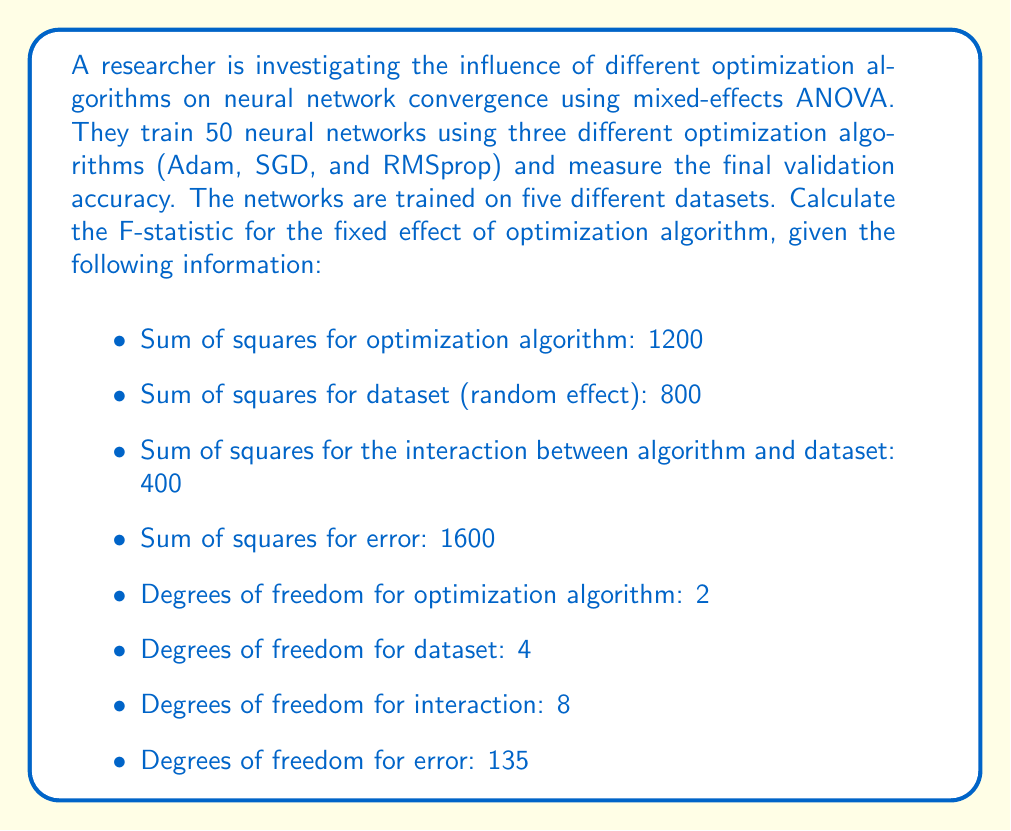Give your solution to this math problem. To calculate the F-statistic for the fixed effect of optimization algorithm in a mixed-effects ANOVA, we need to follow these steps:

1. Calculate the mean square for the optimization algorithm:
   $$MS_{algorithm} = \frac{SS_{algorithm}}{df_{algorithm}} = \frac{1200}{2} = 600$$

2. Calculate the mean square for the interaction between algorithm and dataset:
   $$MS_{interaction} = \frac{SS_{interaction}}{df_{interaction}} = \frac{400}{8} = 50$$

3. In a mixed-effects ANOVA, the appropriate denominator for the F-statistic of a fixed effect is the mean square of the interaction between the fixed effect and the random effect. In this case, it's the interaction between algorithm and dataset.

4. Calculate the F-statistic:
   $$F = \frac{MS_{algorithm}}{MS_{interaction}} = \frac{600}{50} = 12$$

The F-statistic is the ratio of the mean square for the effect of interest (optimization algorithm) to the mean square of the interaction between the fixed and random effects (algorithm and dataset interaction).

This F-statistic with degrees of freedom (2, 8) can be used to determine the statistical significance of the effect of optimization algorithm on neural network convergence, accounting for the variability introduced by different datasets.
Answer: The F-statistic for the fixed effect of optimization algorithm is 12, with degrees of freedom (2, 8). 